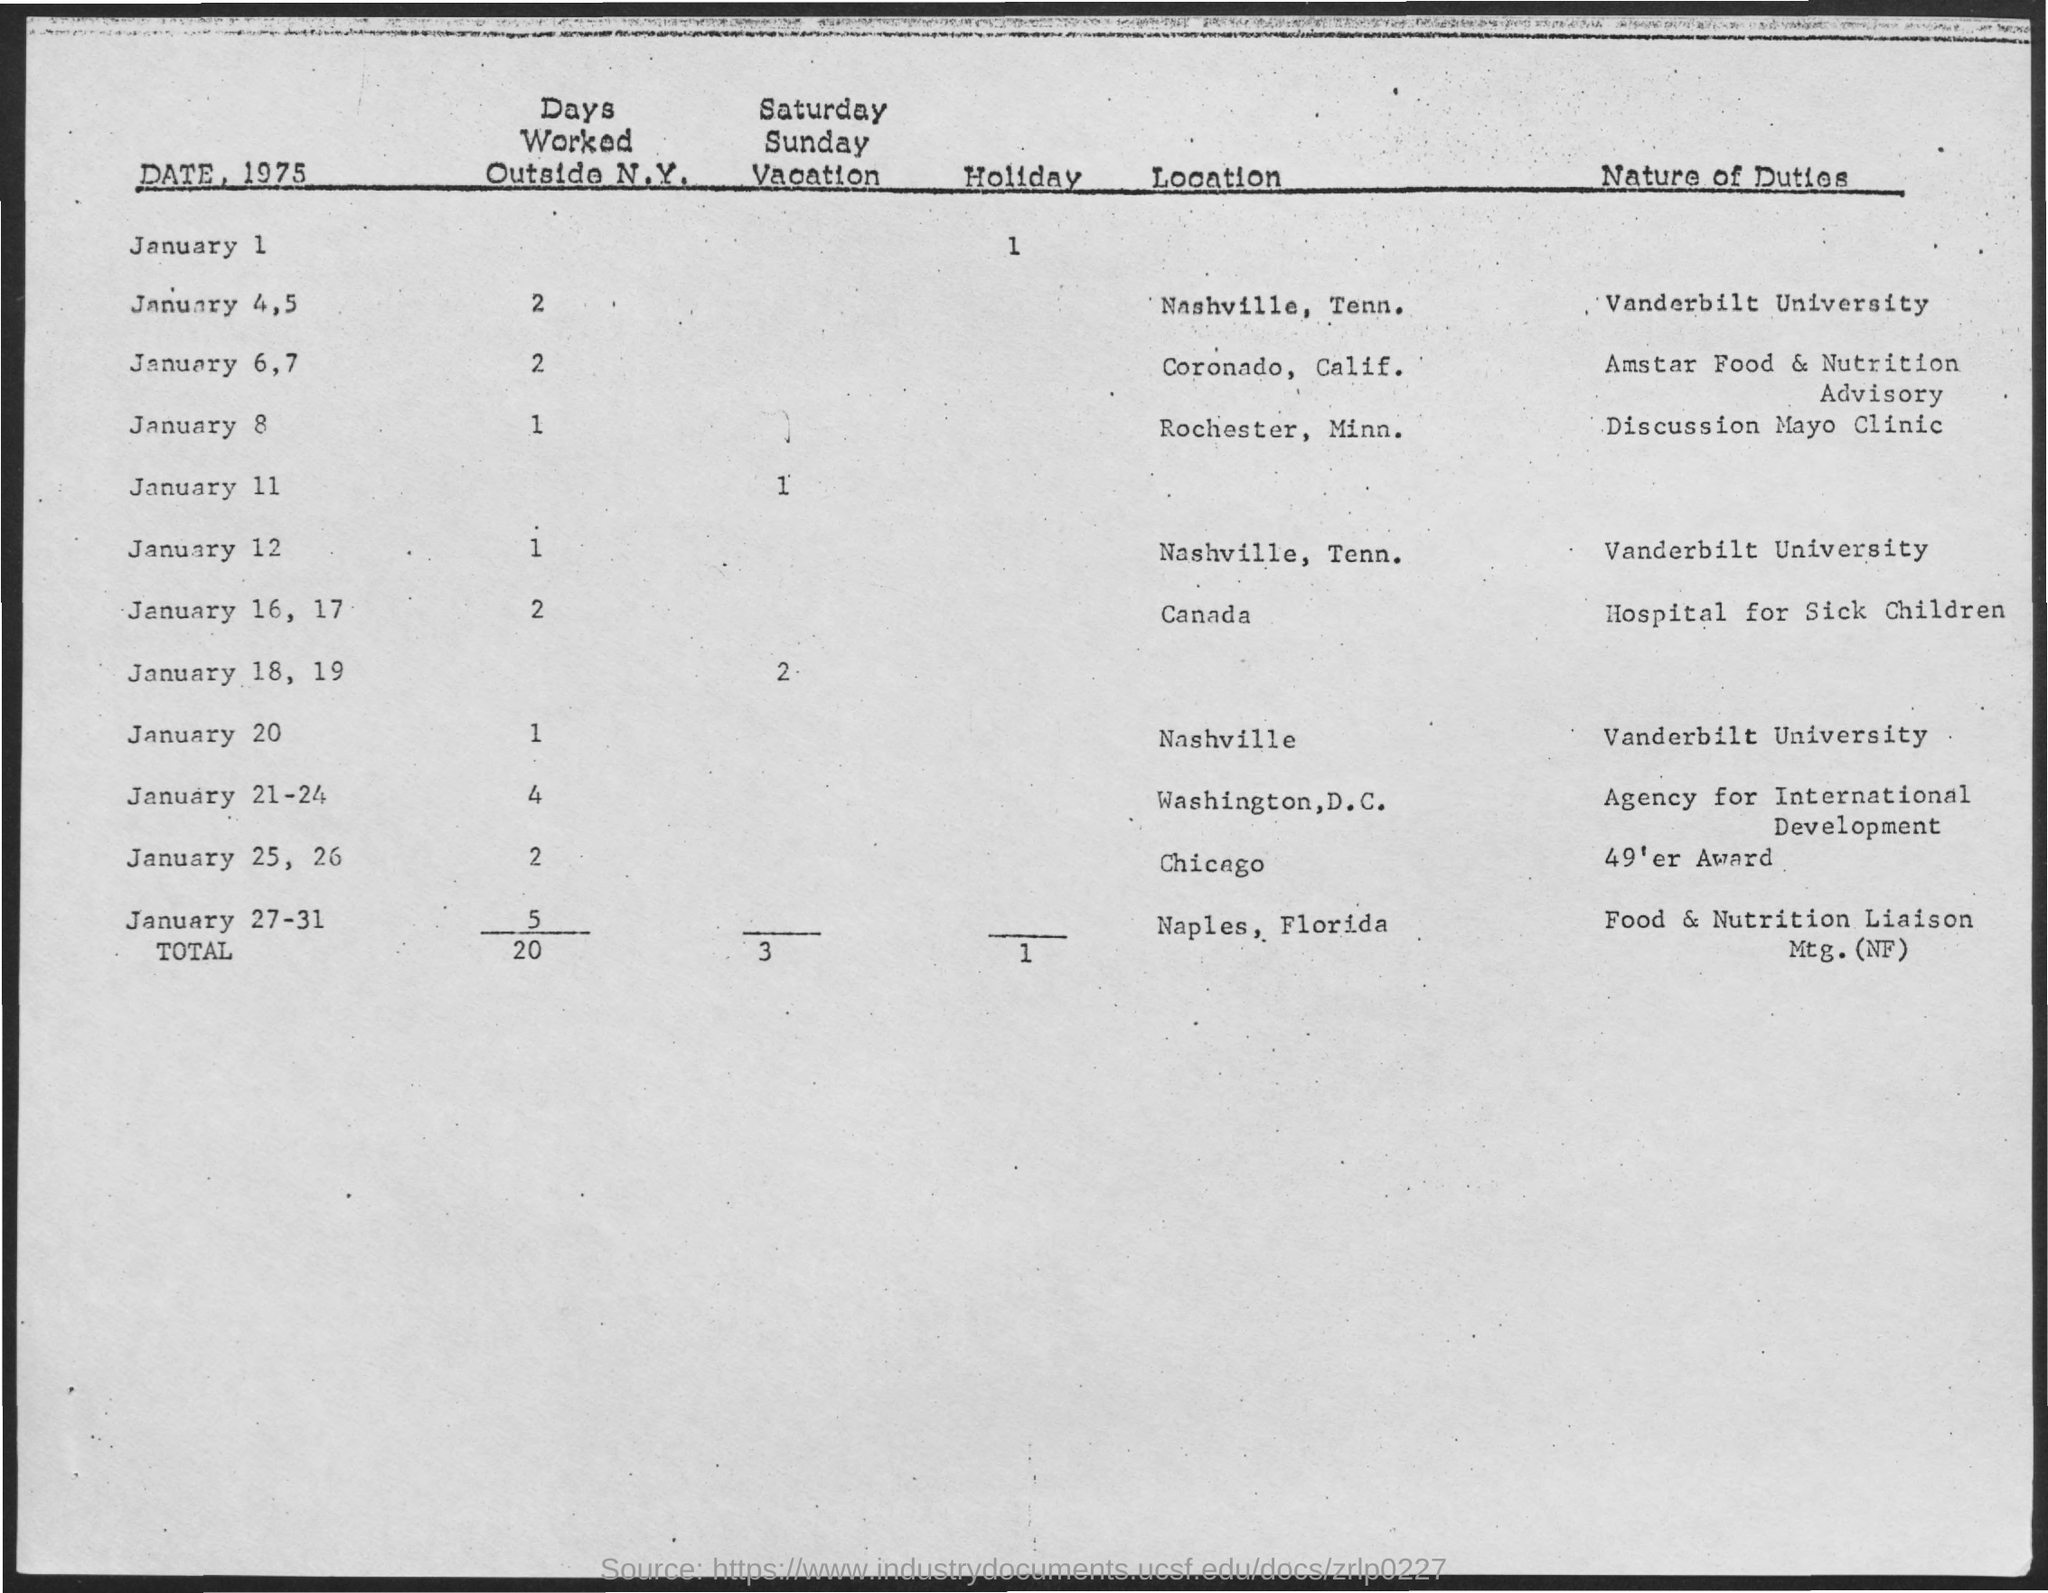What is the total number of days worked outside N.Y.?
Ensure brevity in your answer.  20. What is the total number of holidays?
Provide a short and direct response. 1. What is the nature of duty on January 12?
Provide a short and direct response. Vanderbilt university. What is the nature of duty on January 20?
Make the answer very short. Vanderbilt university. What is the total number of Saturday-Sunday vacations?
Your answer should be compact. 3. What is the number of days worked outside N.Y. on January 8?
Your answer should be compact. 1. 